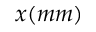Convert formula to latex. <formula><loc_0><loc_0><loc_500><loc_500>x ( m m )</formula> 